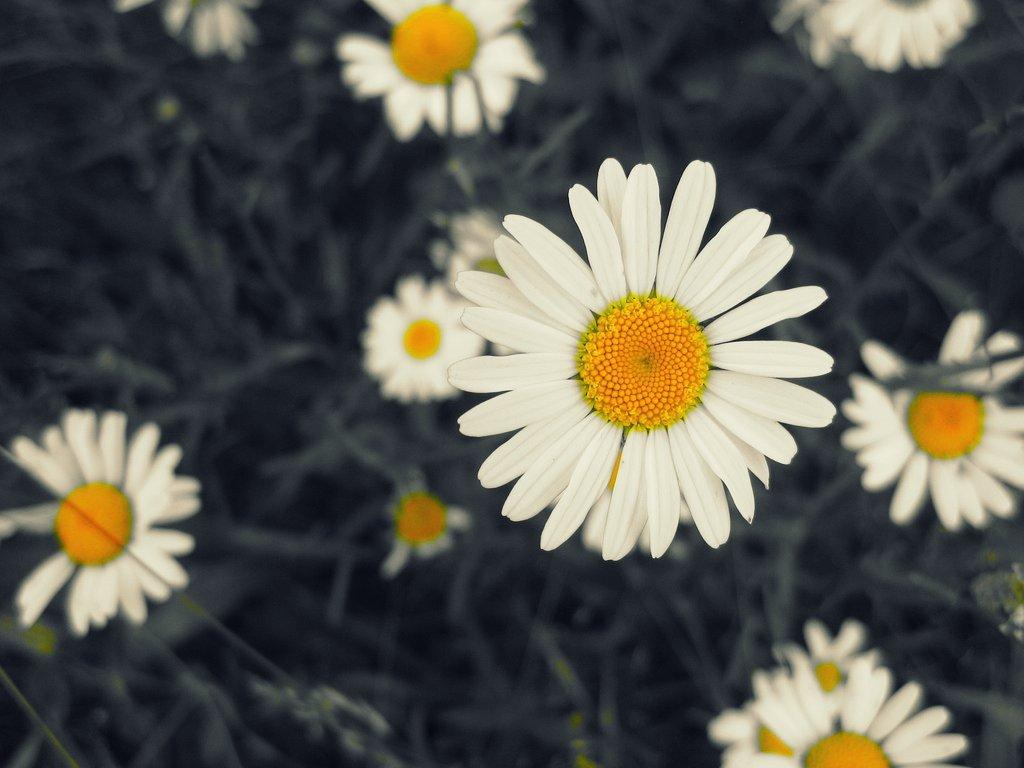What type of objects are present in the image? There are flowers in the image. Can you describe the colors of the flowers? The flowers are white and yellow. What can be observed about the background of the image? The background of the image is blurred. What statement can be made about the group of flowers in the image? There is no group of flowers mentioned in the image; only individual flowers are described. 